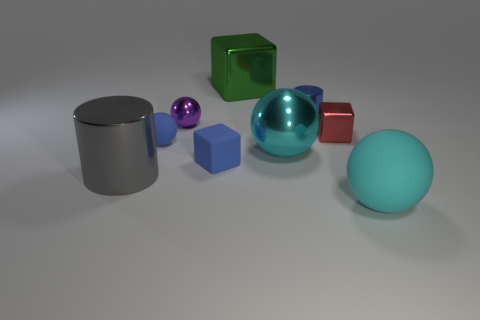Subtract 2 spheres. How many spheres are left? 2 Subtract all gray balls. Subtract all gray cylinders. How many balls are left? 4 Add 1 tiny green cylinders. How many objects exist? 10 Subtract 0 purple cubes. How many objects are left? 9 Subtract all balls. How many objects are left? 5 Subtract all small cyan things. Subtract all big balls. How many objects are left? 7 Add 7 blue shiny cylinders. How many blue shiny cylinders are left? 8 Add 6 small blue cylinders. How many small blue cylinders exist? 7 